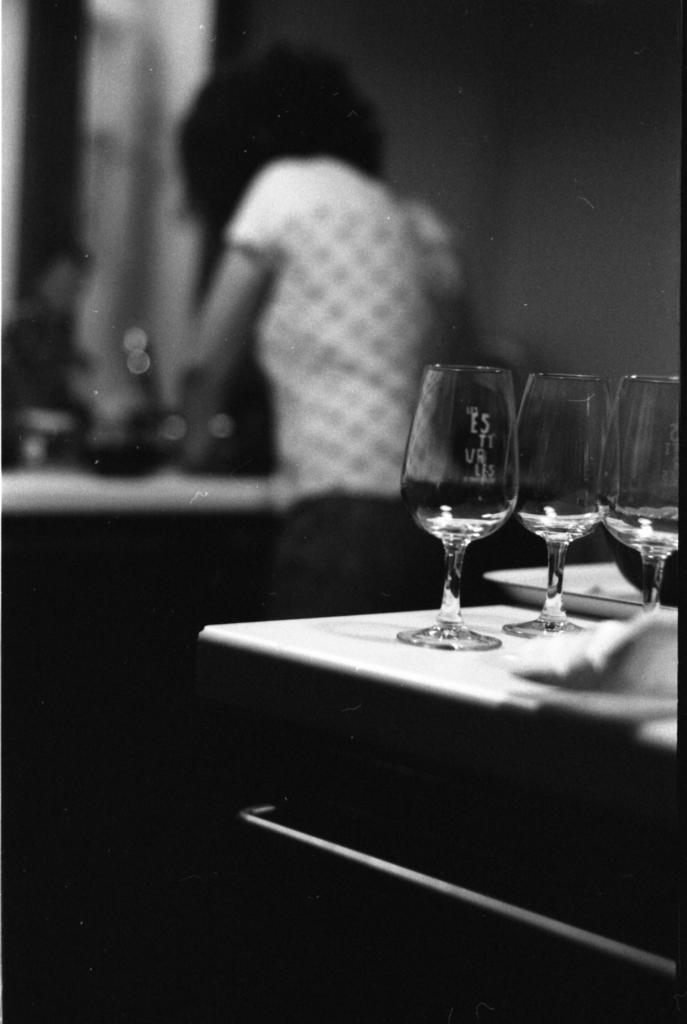What is located in the bottom right corner of the image? There is a table in the bottom right corner of the image. What objects are on the table? There are glasses and plates on the table. Who is present near the table? A person is standing behind the table. What is behind the person? There is a wall behind the person. Can you see a rabbit hopping on the land in the image? There is no rabbit or land present in the image. Is there a chain hanging from the wall behind the person? There is no chain visible in the image. 